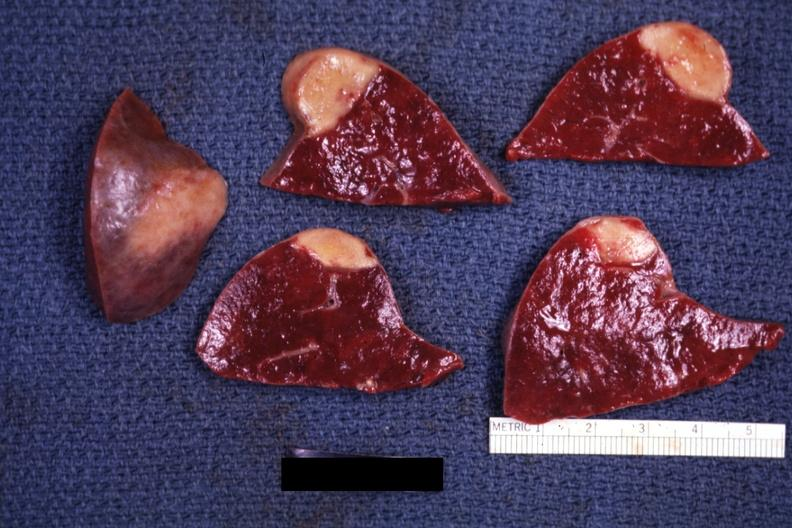s chest and abdomen slide present?
Answer the question using a single word or phrase. No 